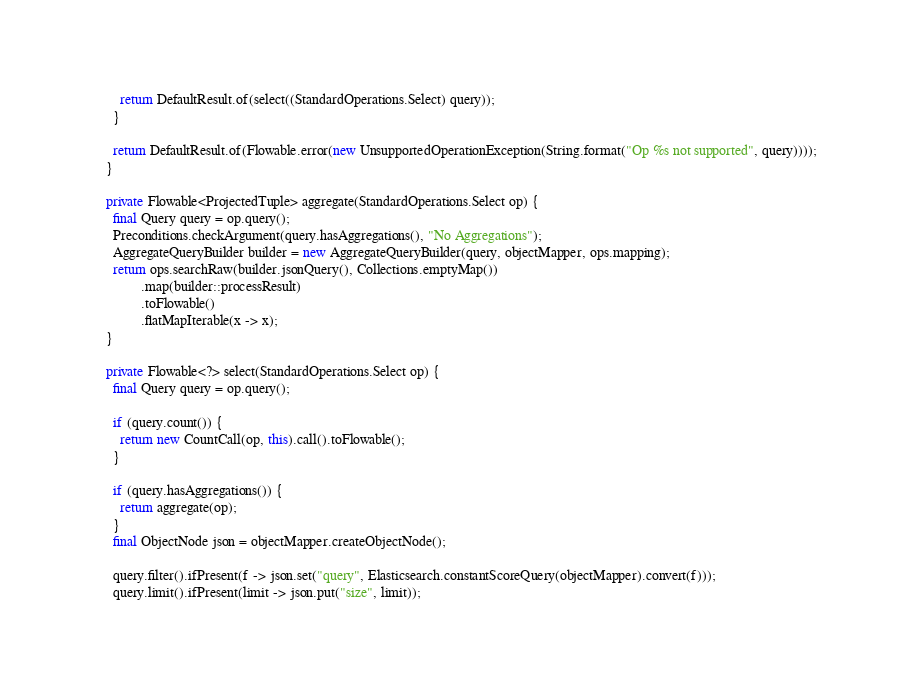<code> <loc_0><loc_0><loc_500><loc_500><_Java_>        return DefaultResult.of(select((StandardOperations.Select) query));
      }

      return DefaultResult.of(Flowable.error(new UnsupportedOperationException(String.format("Op %s not supported", query))));
    }

    private Flowable<ProjectedTuple> aggregate(StandardOperations.Select op) {
      final Query query = op.query();
      Preconditions.checkArgument(query.hasAggregations(), "No Aggregations");
      AggregateQueryBuilder builder = new AggregateQueryBuilder(query, objectMapper, ops.mapping);
      return ops.searchRaw(builder.jsonQuery(), Collections.emptyMap())
              .map(builder::processResult)
              .toFlowable()
              .flatMapIterable(x -> x);
    }

    private Flowable<?> select(StandardOperations.Select op) {
      final Query query = op.query();

      if (query.count()) {
        return new CountCall(op, this).call().toFlowable();
      }

      if (query.hasAggregations()) {
        return aggregate(op);
      }
      final ObjectNode json = objectMapper.createObjectNode();

      query.filter().ifPresent(f -> json.set("query", Elasticsearch.constantScoreQuery(objectMapper).convert(f)));
      query.limit().ifPresent(limit -> json.put("size", limit));</code> 